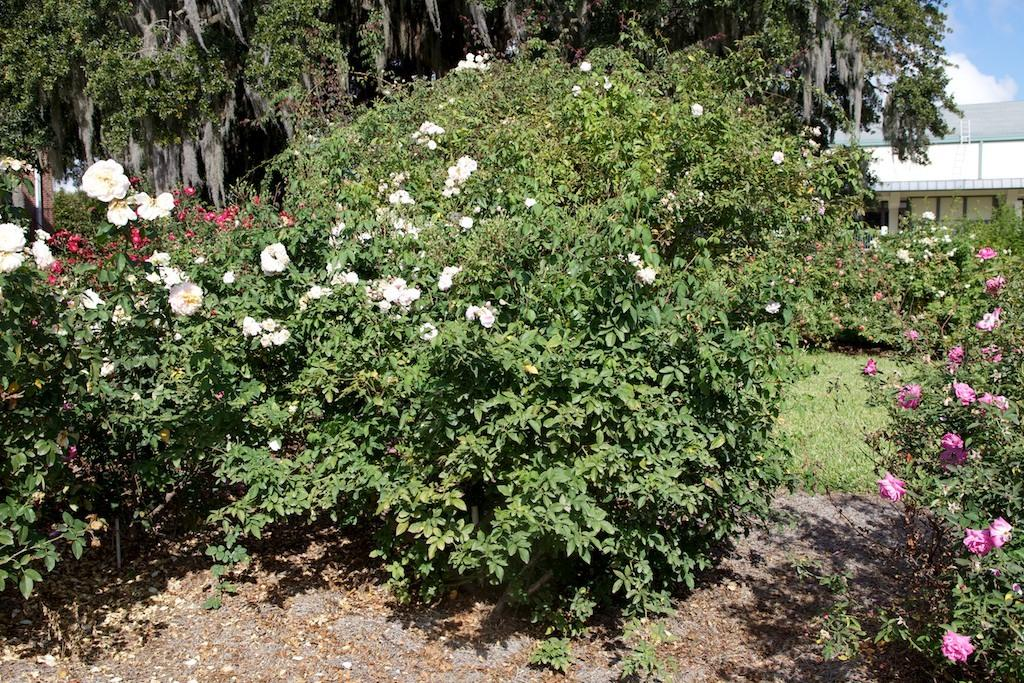What can be seen in the sky in the image? The sky is visible in the image, and there are clouds present. What type of structures can be seen in the image? There are buildings in the image. What type of vegetation is present in the image? Trees, plants with flowers, and grass are visible in the image. What is the ground like in the image? The ground is visible in the image, and there are shredded leaves present. How does the image show an increase in the number of boats? The image does not show any boats, so it cannot demonstrate an increase in their number. 